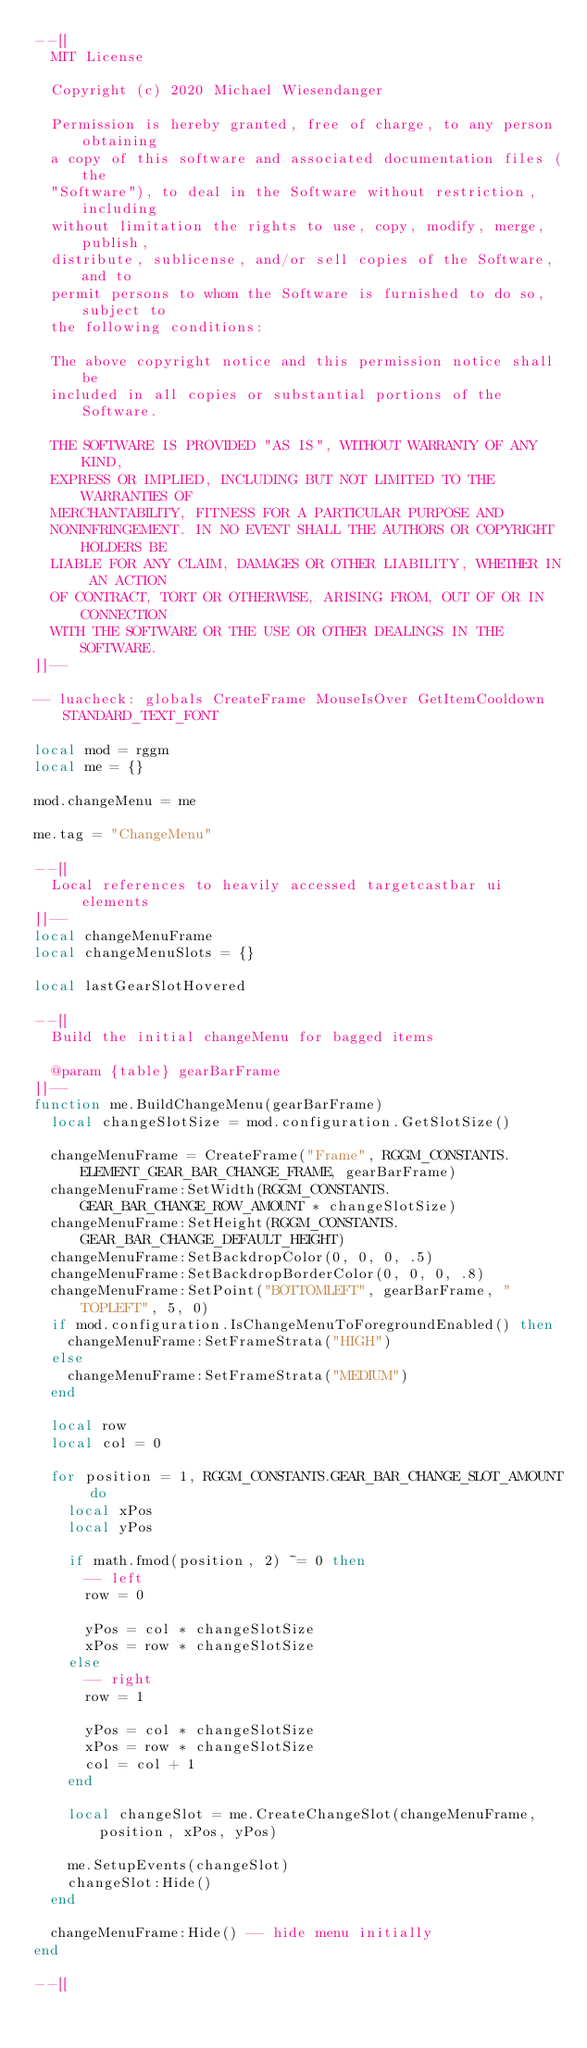Convert code to text. <code><loc_0><loc_0><loc_500><loc_500><_Lua_>--[[
  MIT License

  Copyright (c) 2020 Michael Wiesendanger

  Permission is hereby granted, free of charge, to any person obtaining
  a copy of this software and associated documentation files (the
  "Software"), to deal in the Software without restriction, including
  without limitation the rights to use, copy, modify, merge, publish,
  distribute, sublicense, and/or sell copies of the Software, and to
  permit persons to whom the Software is furnished to do so, subject to
  the following conditions:

  The above copyright notice and this permission notice shall be
  included in all copies or substantial portions of the Software.

  THE SOFTWARE IS PROVIDED "AS IS", WITHOUT WARRANTY OF ANY KIND,
  EXPRESS OR IMPLIED, INCLUDING BUT NOT LIMITED TO THE WARRANTIES OF
  MERCHANTABILITY, FITNESS FOR A PARTICULAR PURPOSE AND
  NONINFRINGEMENT. IN NO EVENT SHALL THE AUTHORS OR COPYRIGHT HOLDERS BE
  LIABLE FOR ANY CLAIM, DAMAGES OR OTHER LIABILITY, WHETHER IN AN ACTION
  OF CONTRACT, TORT OR OTHERWISE, ARISING FROM, OUT OF OR IN CONNECTION
  WITH THE SOFTWARE OR THE USE OR OTHER DEALINGS IN THE SOFTWARE.
]]--

-- luacheck: globals CreateFrame MouseIsOver GetItemCooldown STANDARD_TEXT_FONT

local mod = rggm
local me = {}

mod.changeMenu = me

me.tag = "ChangeMenu"

--[[
  Local references to heavily accessed targetcastbar ui elements
]]--
local changeMenuFrame
local changeMenuSlots = {}

local lastGearSlotHovered

--[[
  Build the initial changeMenu for bagged items

  @param {table} gearBarFrame
]]--
function me.BuildChangeMenu(gearBarFrame)
  local changeSlotSize = mod.configuration.GetSlotSize()

  changeMenuFrame = CreateFrame("Frame", RGGM_CONSTANTS.ELEMENT_GEAR_BAR_CHANGE_FRAME, gearBarFrame)
  changeMenuFrame:SetWidth(RGGM_CONSTANTS.GEAR_BAR_CHANGE_ROW_AMOUNT * changeSlotSize)
  changeMenuFrame:SetHeight(RGGM_CONSTANTS.GEAR_BAR_CHANGE_DEFAULT_HEIGHT)
  changeMenuFrame:SetBackdropColor(0, 0, 0, .5)
  changeMenuFrame:SetBackdropBorderColor(0, 0, 0, .8)
  changeMenuFrame:SetPoint("BOTTOMLEFT", gearBarFrame, "TOPLEFT", 5, 0)
  if mod.configuration.IsChangeMenuToForegroundEnabled() then
    changeMenuFrame:SetFrameStrata("HIGH")
  else
    changeMenuFrame:SetFrameStrata("MEDIUM")
  end

  local row
  local col = 0

  for position = 1, RGGM_CONSTANTS.GEAR_BAR_CHANGE_SLOT_AMOUNT do
    local xPos
    local yPos

    if math.fmod(position, 2) ~= 0 then
      -- left
      row = 0

      yPos = col * changeSlotSize
      xPos = row * changeSlotSize
    else
      -- right
      row = 1

      yPos = col * changeSlotSize
      xPos = row * changeSlotSize
      col = col + 1
    end

    local changeSlot = me.CreateChangeSlot(changeMenuFrame, position, xPos, yPos)

    me.SetupEvents(changeSlot)
    changeSlot:Hide()
  end

  changeMenuFrame:Hide() -- hide menu initially
end

--[[</code> 